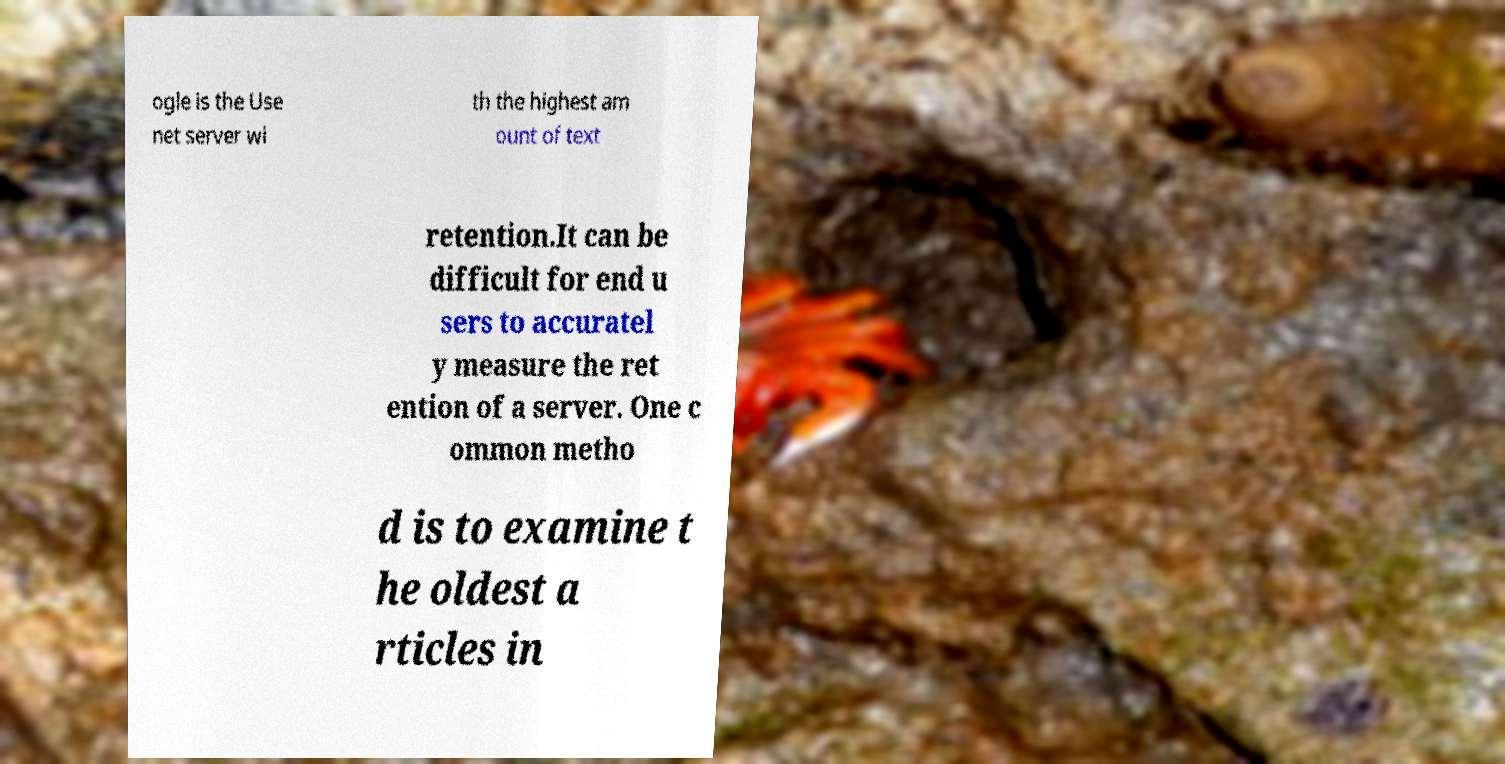Can you accurately transcribe the text from the provided image for me? ogle is the Use net server wi th the highest am ount of text retention.It can be difficult for end u sers to accuratel y measure the ret ention of a server. One c ommon metho d is to examine t he oldest a rticles in 